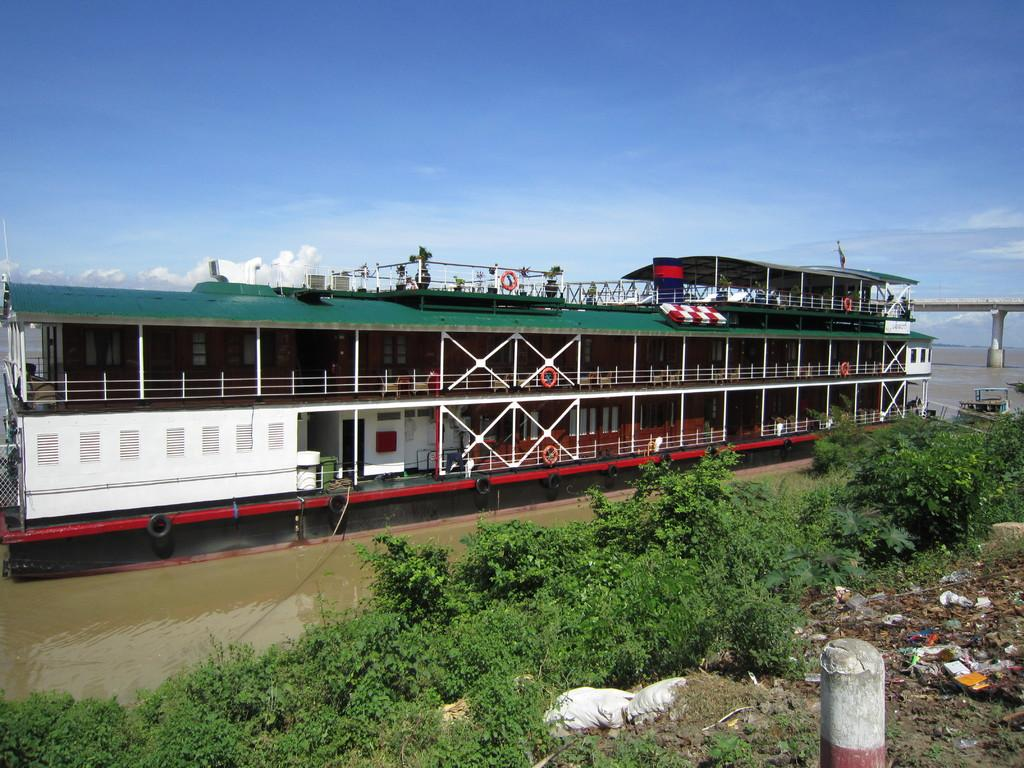What is the main subject of the image? There is a ship in the image. Where is the ship located? The ship is in the water. What else can be seen in the image besides the ship? There is water, a bridge, grass, garbage, and a cloudy sky visible in the image. How many snails can be seen crawling on the door in the image? There are no snails or doors present in the image. What type of coil is used to secure the ship in the image? There is no coil visible in the image; the ship is in the water. 